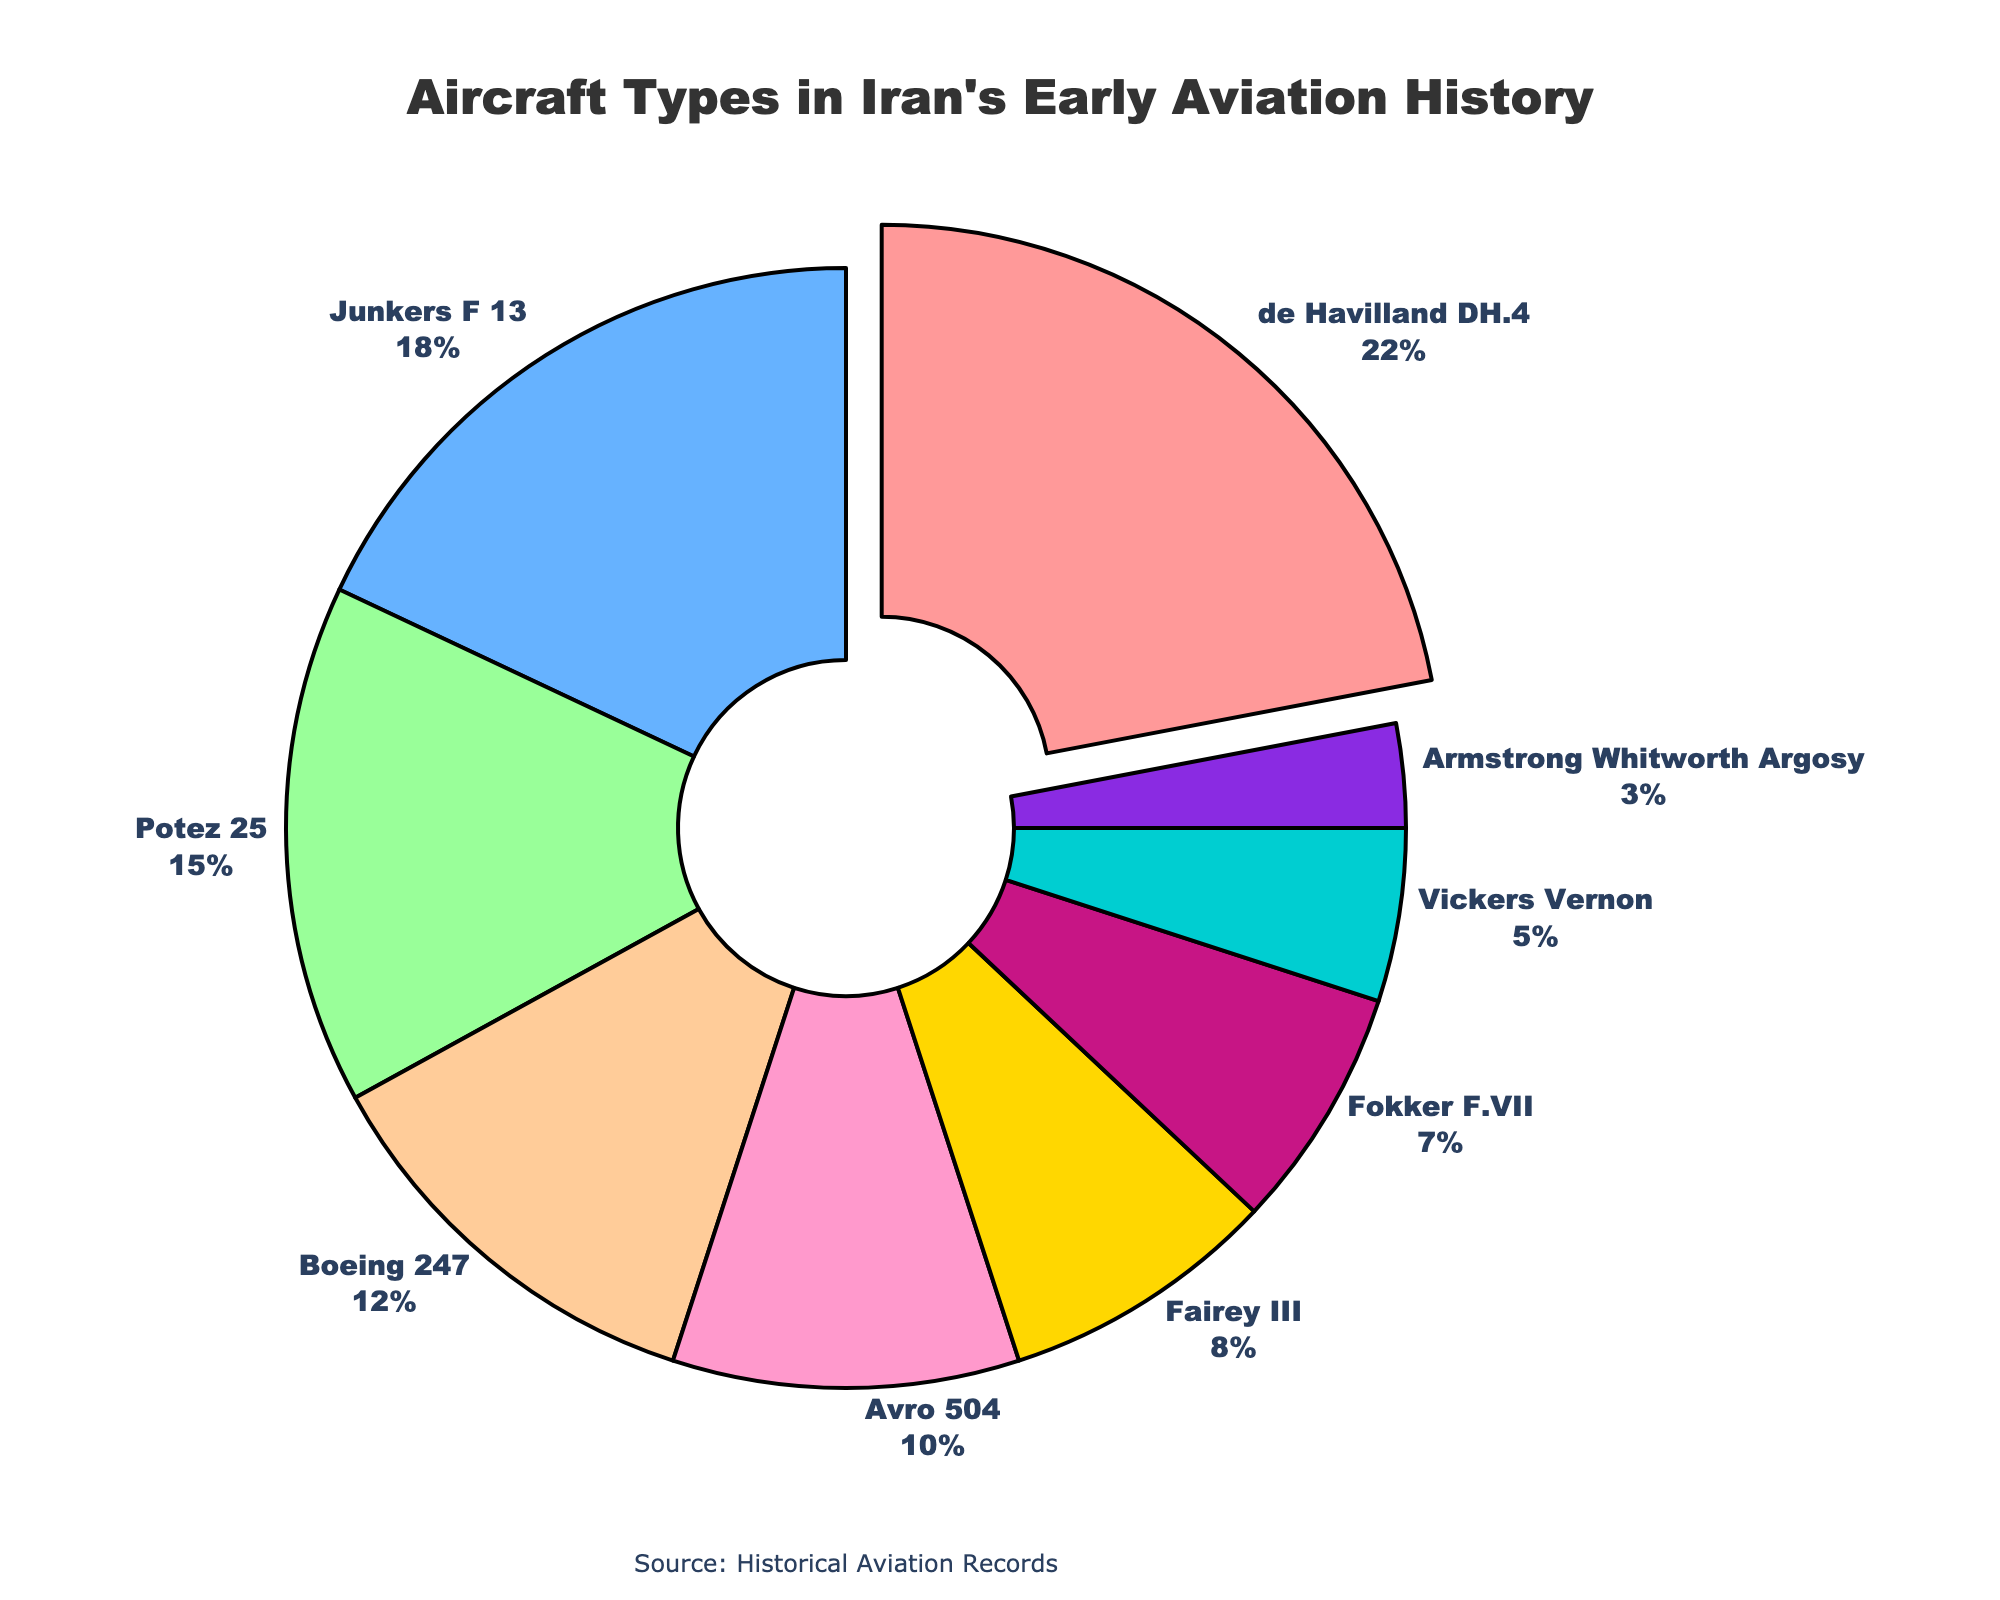What is the percentage of the most widely used aircraft type? The pie chart shows that the de Havilland DH.4 is the most widely used aircraft type, occupying the largest segment, and its percentage is displayed.
Answer: 22% What is the combined percentage of the Junkers F 13 and the Boeing 247? Add the percentage values for Junkers F 13 (18%) and Boeing 247 (12%). 18% + 12% = 30%
Answer: 30% Which aircraft type has the smallest percentage in Iran's early aviation history? The pie chart shows the smallest segment is occupied by the Armstrong Whitworth Argosy.
Answer: Armstrong Whitworth Argosy How much larger is the segment for the de Havilland DH.4 compared to the Vickers Vernon? Subtract the percentage of Vickers Vernon (5%) from the de Havilland DH.4 (22%). 22% - 5% = 17%
Answer: 17% Are there more aircraft types with percentages above or below 10%? Count the aircraft types above 10% (de Havilland DH.4, Junkers F 13, Potez 25, Boeing 247) and below 10% (Avro 504, Fairey III, Fokker F.VII, Vickers Vernon, Armstrong Whitworth Argosy). There are 4 above and 5 below.
Answer: Below 10% What is the sum of the percentages for the de Havilland DH.4, Junkers F 13, and Potez 25? Add the percentages for de Havilland DH.4 (22%), Junkers F 13 (18%), and Potez 25 (15%). 22% + 18% + 15% = 55%
Answer: 55% Which aircraft types have their percentages within the 5% to 10% range, inclusive? Identify the aircraft types whose segments fall in the 5% to 10% range: Avro 504 (10%), Fairey III (8%), and Vickers Vernon (5%).
Answer: Avro 504, Fairey III, Vickers Vernon How does the size of the Avro 504 segment compare to the Fairey III segment? The Avro 504 segment occupies 10% of the chart, while the Fairey III occupies 8%. Therefore, the Avro 504 segment is larger by 2%.
Answer: Avro 504's segment is larger Which segment is visually pulled out from the rest of the pie chart? Notice the visual effect where one segment is slightly separated from the pie chart, indicating emphasis. This segment belongs to the de Havilland DH.4.
Answer: de Havilland DH.4 What is the total percentage of the aircraft types less frequently used than the Boeing 247? Sum the percentages of all aircraft types having less than 12%: Avro 504 (10%), Fairey III (8%), Fokker F.VII (7%), Vickers Vernon (5%), Armstrong Whitworth Argosy (3%). 10% + 8% + 7% + 5% + 3% = 33%
Answer: 33% 